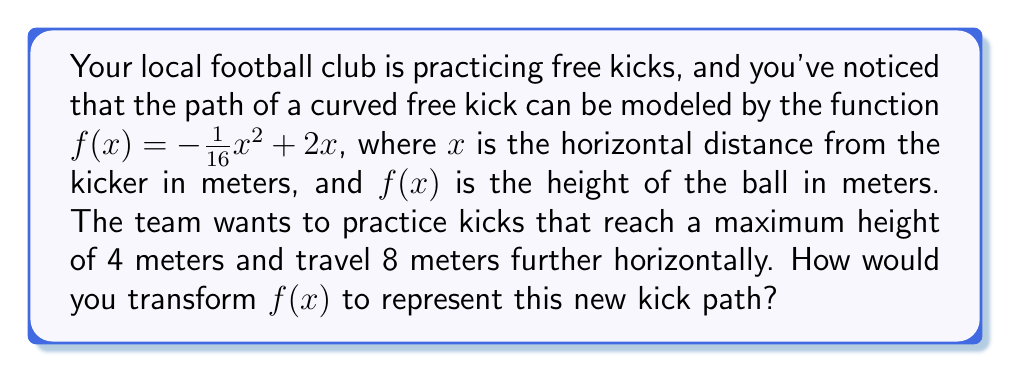What is the answer to this math problem? To transform the function $f(x) = -\frac{1}{16}x^2 + 2x$ to represent the new kick path, we need to apply vertical stretching and horizontal translation.

1. Vertical stretch:
   The original function has a maximum height of 2 meters (when $x = 8$). To reach a maximum height of 4 meters, we need to stretch the function vertically by a factor of 2.
   Apply $2f(x)$: $2(-\frac{1}{16}x^2 + 2x) = -\frac{1}{8}x^2 + 4x$

2. Horizontal translation:
   To make the kick travel 8 meters further horizontally, we need to shift the function 8 units to the right.
   Apply $f(x-8)$: $-\frac{1}{8}(x-8)^2 + 4(x-8)$

3. Expand the expression:
   $-\frac{1}{8}(x^2 - 16x + 64) + 4x - 32$
   $= -\frac{1}{8}x^2 + 2x - 8 + 4x - 32$
   $= -\frac{1}{8}x^2 + 6x - 40$

Therefore, the transformed function representing the new kick path is:
$g(x) = -\frac{1}{8}x^2 + 6x - 40$
Answer: $g(x) = -\frac{1}{8}x^2 + 6x - 40$ 